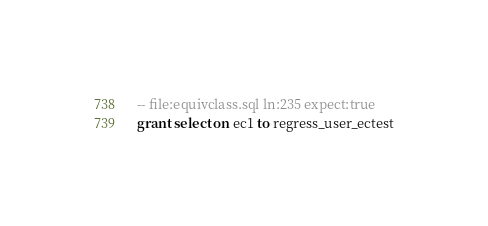<code> <loc_0><loc_0><loc_500><loc_500><_SQL_>-- file:equivclass.sql ln:235 expect:true
grant select on ec1 to regress_user_ectest
</code> 